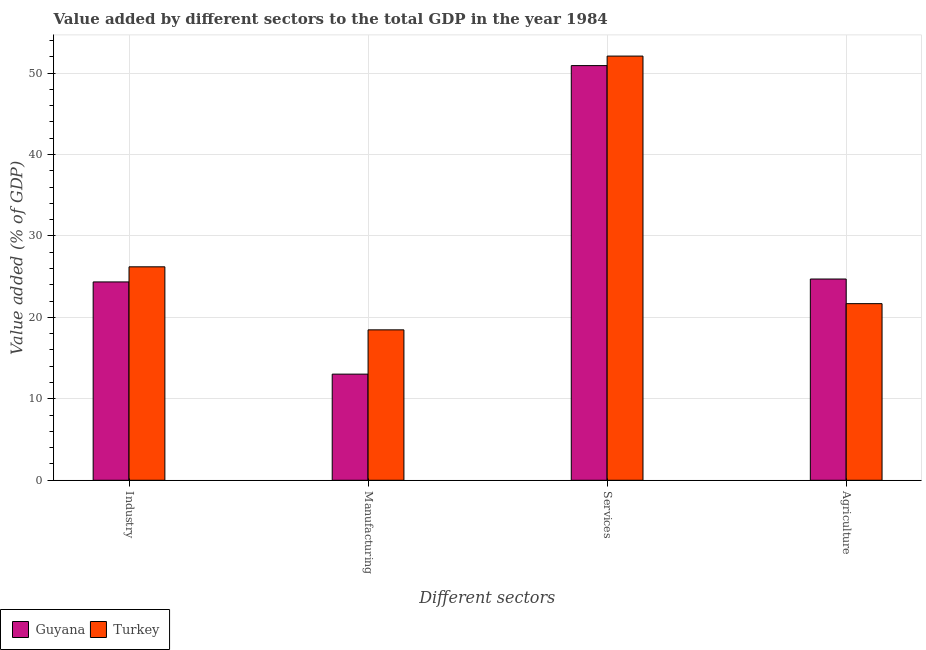How many groups of bars are there?
Keep it short and to the point. 4. Are the number of bars on each tick of the X-axis equal?
Ensure brevity in your answer.  Yes. What is the label of the 3rd group of bars from the left?
Give a very brief answer. Services. What is the value added by agricultural sector in Turkey?
Offer a very short reply. 21.69. Across all countries, what is the maximum value added by manufacturing sector?
Your answer should be compact. 18.47. Across all countries, what is the minimum value added by agricultural sector?
Give a very brief answer. 21.69. In which country was the value added by agricultural sector maximum?
Offer a very short reply. Guyana. In which country was the value added by services sector minimum?
Your answer should be compact. Guyana. What is the total value added by manufacturing sector in the graph?
Offer a very short reply. 31.51. What is the difference between the value added by manufacturing sector in Turkey and that in Guyana?
Your answer should be very brief. 5.44. What is the difference between the value added by agricultural sector in Guyana and the value added by industrial sector in Turkey?
Provide a short and direct response. -1.5. What is the average value added by agricultural sector per country?
Your response must be concise. 23.2. What is the difference between the value added by agricultural sector and value added by industrial sector in Guyana?
Offer a terse response. 0.36. In how many countries, is the value added by industrial sector greater than 28 %?
Your response must be concise. 0. What is the ratio of the value added by manufacturing sector in Guyana to that in Turkey?
Give a very brief answer. 0.71. Is the value added by manufacturing sector in Guyana less than that in Turkey?
Give a very brief answer. Yes. What is the difference between the highest and the second highest value added by services sector?
Offer a terse response. 1.17. What is the difference between the highest and the lowest value added by industrial sector?
Provide a short and direct response. 1.86. Is the sum of the value added by industrial sector in Guyana and Turkey greater than the maximum value added by agricultural sector across all countries?
Your answer should be compact. Yes. What does the 2nd bar from the left in Industry represents?
Provide a succinct answer. Turkey. What does the 2nd bar from the right in Services represents?
Ensure brevity in your answer.  Guyana. Is it the case that in every country, the sum of the value added by industrial sector and value added by manufacturing sector is greater than the value added by services sector?
Keep it short and to the point. No. Are all the bars in the graph horizontal?
Ensure brevity in your answer.  No. How many countries are there in the graph?
Offer a very short reply. 2. Are the values on the major ticks of Y-axis written in scientific E-notation?
Your response must be concise. No. Does the graph contain grids?
Make the answer very short. Yes. How many legend labels are there?
Offer a terse response. 2. What is the title of the graph?
Offer a terse response. Value added by different sectors to the total GDP in the year 1984. Does "Low income" appear as one of the legend labels in the graph?
Keep it short and to the point. No. What is the label or title of the X-axis?
Offer a terse response. Different sectors. What is the label or title of the Y-axis?
Your response must be concise. Value added (% of GDP). What is the Value added (% of GDP) in Guyana in Industry?
Give a very brief answer. 24.36. What is the Value added (% of GDP) of Turkey in Industry?
Offer a terse response. 26.21. What is the Value added (% of GDP) of Guyana in Manufacturing?
Offer a very short reply. 13.03. What is the Value added (% of GDP) of Turkey in Manufacturing?
Your answer should be compact. 18.47. What is the Value added (% of GDP) of Guyana in Services?
Keep it short and to the point. 50.93. What is the Value added (% of GDP) in Turkey in Services?
Make the answer very short. 52.1. What is the Value added (% of GDP) in Guyana in Agriculture?
Your response must be concise. 24.72. What is the Value added (% of GDP) of Turkey in Agriculture?
Ensure brevity in your answer.  21.69. Across all Different sectors, what is the maximum Value added (% of GDP) of Guyana?
Provide a short and direct response. 50.93. Across all Different sectors, what is the maximum Value added (% of GDP) of Turkey?
Provide a short and direct response. 52.1. Across all Different sectors, what is the minimum Value added (% of GDP) of Guyana?
Give a very brief answer. 13.03. Across all Different sectors, what is the minimum Value added (% of GDP) of Turkey?
Provide a short and direct response. 18.47. What is the total Value added (% of GDP) in Guyana in the graph?
Offer a very short reply. 113.03. What is the total Value added (% of GDP) in Turkey in the graph?
Make the answer very short. 118.47. What is the difference between the Value added (% of GDP) in Guyana in Industry and that in Manufacturing?
Offer a terse response. 11.32. What is the difference between the Value added (% of GDP) in Turkey in Industry and that in Manufacturing?
Your response must be concise. 7.74. What is the difference between the Value added (% of GDP) of Guyana in Industry and that in Services?
Your answer should be compact. -26.57. What is the difference between the Value added (% of GDP) in Turkey in Industry and that in Services?
Provide a short and direct response. -25.88. What is the difference between the Value added (% of GDP) in Guyana in Industry and that in Agriculture?
Give a very brief answer. -0.36. What is the difference between the Value added (% of GDP) of Turkey in Industry and that in Agriculture?
Provide a succinct answer. 4.52. What is the difference between the Value added (% of GDP) of Guyana in Manufacturing and that in Services?
Offer a very short reply. -37.89. What is the difference between the Value added (% of GDP) of Turkey in Manufacturing and that in Services?
Your answer should be very brief. -33.62. What is the difference between the Value added (% of GDP) in Guyana in Manufacturing and that in Agriculture?
Keep it short and to the point. -11.68. What is the difference between the Value added (% of GDP) of Turkey in Manufacturing and that in Agriculture?
Provide a succinct answer. -3.22. What is the difference between the Value added (% of GDP) of Guyana in Services and that in Agriculture?
Your answer should be very brief. 26.21. What is the difference between the Value added (% of GDP) in Turkey in Services and that in Agriculture?
Give a very brief answer. 30.4. What is the difference between the Value added (% of GDP) of Guyana in Industry and the Value added (% of GDP) of Turkey in Manufacturing?
Your response must be concise. 5.89. What is the difference between the Value added (% of GDP) in Guyana in Industry and the Value added (% of GDP) in Turkey in Services?
Your response must be concise. -27.74. What is the difference between the Value added (% of GDP) in Guyana in Industry and the Value added (% of GDP) in Turkey in Agriculture?
Provide a short and direct response. 2.67. What is the difference between the Value added (% of GDP) of Guyana in Manufacturing and the Value added (% of GDP) of Turkey in Services?
Make the answer very short. -39.06. What is the difference between the Value added (% of GDP) of Guyana in Manufacturing and the Value added (% of GDP) of Turkey in Agriculture?
Make the answer very short. -8.66. What is the difference between the Value added (% of GDP) in Guyana in Services and the Value added (% of GDP) in Turkey in Agriculture?
Ensure brevity in your answer.  29.24. What is the average Value added (% of GDP) in Guyana per Different sectors?
Your answer should be compact. 28.26. What is the average Value added (% of GDP) of Turkey per Different sectors?
Make the answer very short. 29.62. What is the difference between the Value added (% of GDP) of Guyana and Value added (% of GDP) of Turkey in Industry?
Ensure brevity in your answer.  -1.86. What is the difference between the Value added (% of GDP) of Guyana and Value added (% of GDP) of Turkey in Manufacturing?
Give a very brief answer. -5.44. What is the difference between the Value added (% of GDP) of Guyana and Value added (% of GDP) of Turkey in Services?
Keep it short and to the point. -1.17. What is the difference between the Value added (% of GDP) of Guyana and Value added (% of GDP) of Turkey in Agriculture?
Your answer should be compact. 3.02. What is the ratio of the Value added (% of GDP) in Guyana in Industry to that in Manufacturing?
Your answer should be very brief. 1.87. What is the ratio of the Value added (% of GDP) of Turkey in Industry to that in Manufacturing?
Offer a terse response. 1.42. What is the ratio of the Value added (% of GDP) in Guyana in Industry to that in Services?
Offer a very short reply. 0.48. What is the ratio of the Value added (% of GDP) in Turkey in Industry to that in Services?
Your response must be concise. 0.5. What is the ratio of the Value added (% of GDP) of Guyana in Industry to that in Agriculture?
Offer a very short reply. 0.99. What is the ratio of the Value added (% of GDP) of Turkey in Industry to that in Agriculture?
Keep it short and to the point. 1.21. What is the ratio of the Value added (% of GDP) of Guyana in Manufacturing to that in Services?
Offer a terse response. 0.26. What is the ratio of the Value added (% of GDP) of Turkey in Manufacturing to that in Services?
Make the answer very short. 0.35. What is the ratio of the Value added (% of GDP) of Guyana in Manufacturing to that in Agriculture?
Offer a terse response. 0.53. What is the ratio of the Value added (% of GDP) of Turkey in Manufacturing to that in Agriculture?
Provide a short and direct response. 0.85. What is the ratio of the Value added (% of GDP) in Guyana in Services to that in Agriculture?
Provide a short and direct response. 2.06. What is the ratio of the Value added (% of GDP) of Turkey in Services to that in Agriculture?
Give a very brief answer. 2.4. What is the difference between the highest and the second highest Value added (% of GDP) in Guyana?
Provide a succinct answer. 26.21. What is the difference between the highest and the second highest Value added (% of GDP) in Turkey?
Give a very brief answer. 25.88. What is the difference between the highest and the lowest Value added (% of GDP) in Guyana?
Your answer should be very brief. 37.89. What is the difference between the highest and the lowest Value added (% of GDP) in Turkey?
Provide a short and direct response. 33.62. 